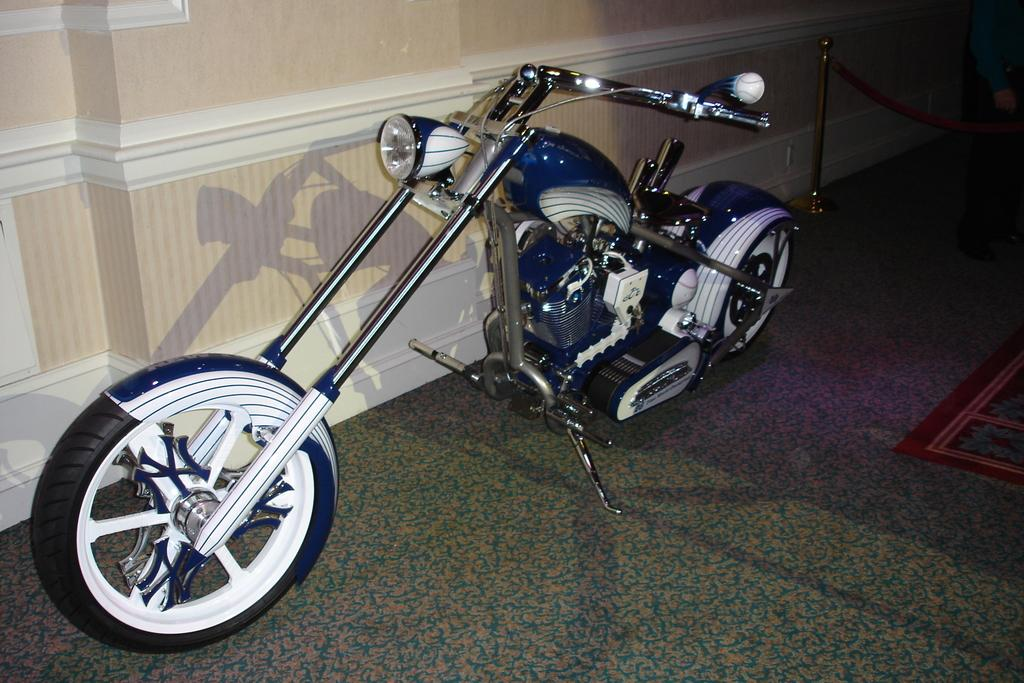What is the main subject in the middle of the image? There is a motorbike in the middle of the image. What can be seen at the bottom of the image? The floor is visible at the bottom of the image. What is located at the top of the image? There is a well at the top of the image. What type of ink is being used to write on the motorbike in the image? There is no ink or writing present on the motorbike in the image. Can you tell me the name of the governor who is standing next to the well in the image? There is no person, including a governor, present in the image. 